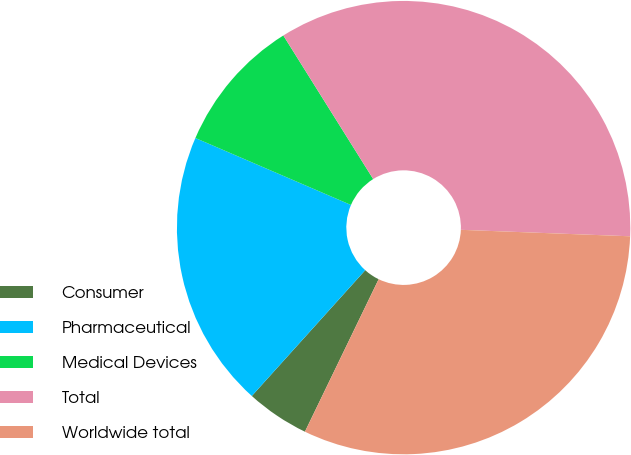Convert chart. <chart><loc_0><loc_0><loc_500><loc_500><pie_chart><fcel>Consumer<fcel>Pharmaceutical<fcel>Medical Devices<fcel>Total<fcel>Worldwide total<nl><fcel>4.51%<fcel>19.79%<fcel>9.63%<fcel>34.51%<fcel>31.56%<nl></chart> 